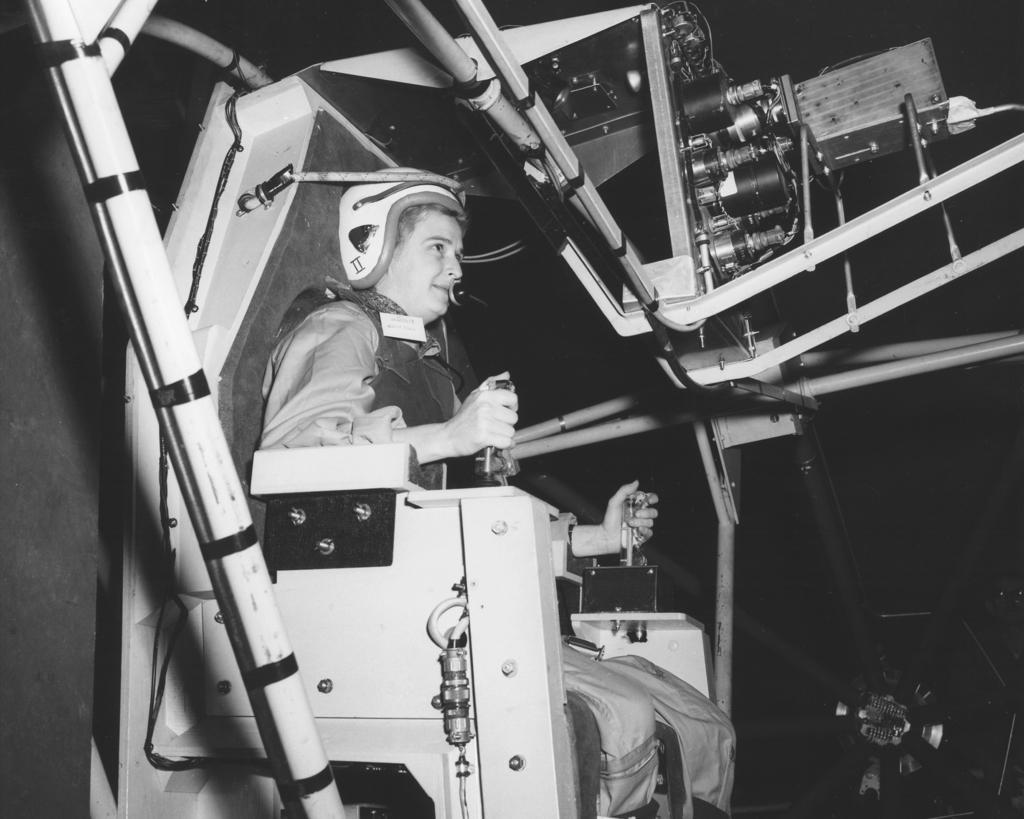Could you give a brief overview of what you see in this image? In the foreground of this image, there is a person sitting on the space shuttle seat and operating it. 